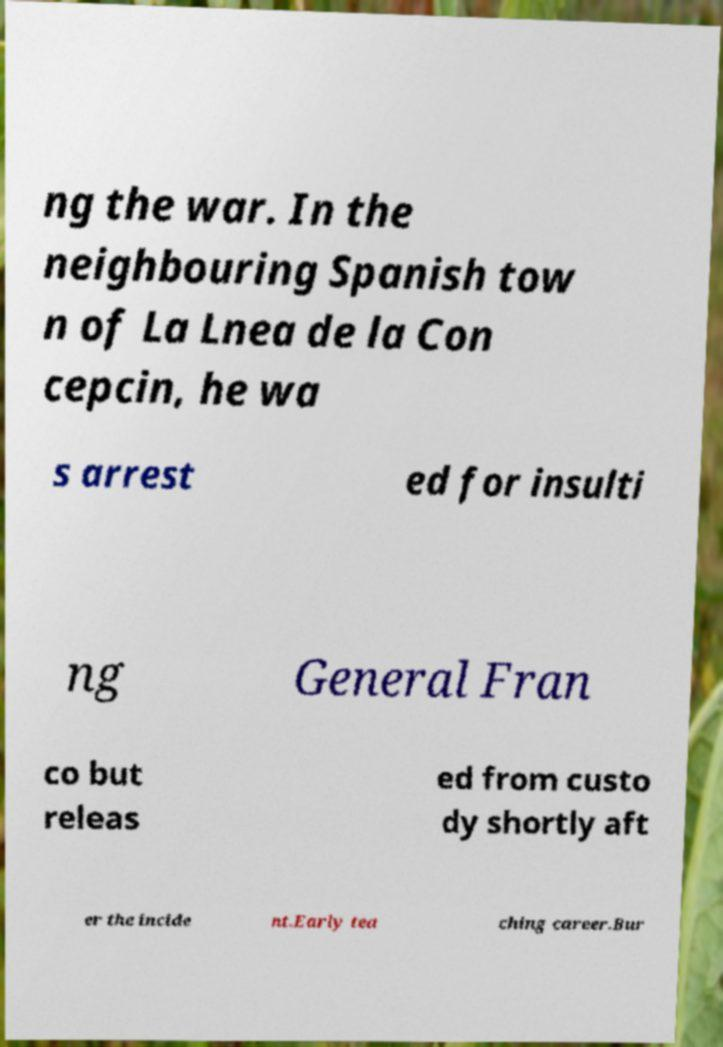Please read and relay the text visible in this image. What does it say? ng the war. In the neighbouring Spanish tow n of La Lnea de la Con cepcin, he wa s arrest ed for insulti ng General Fran co but releas ed from custo dy shortly aft er the incide nt.Early tea ching career.Bur 